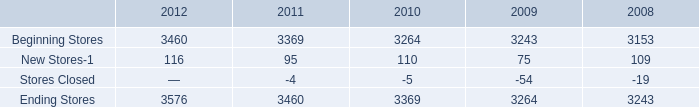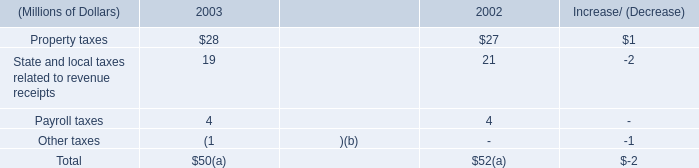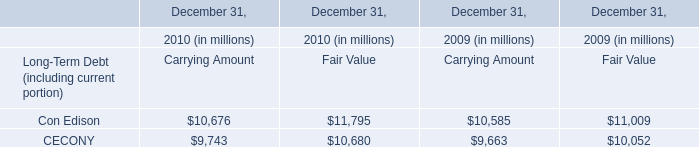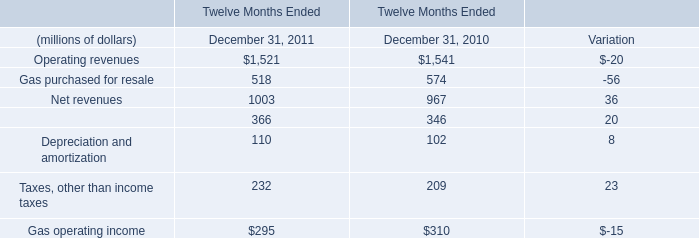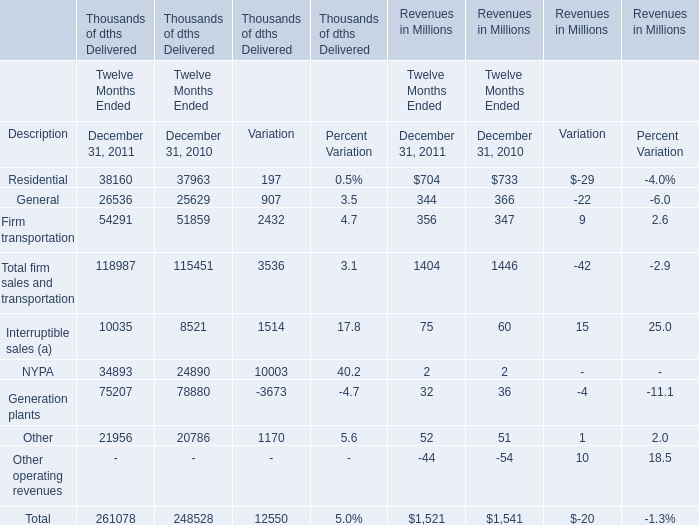What will Operating revenues reach in 2012 if it continues to grow at its current rate? (in million) 
Computations: (1521 + ((1521 * (1521 - 1541)) / 1541))
Answer: 1501.25957. 